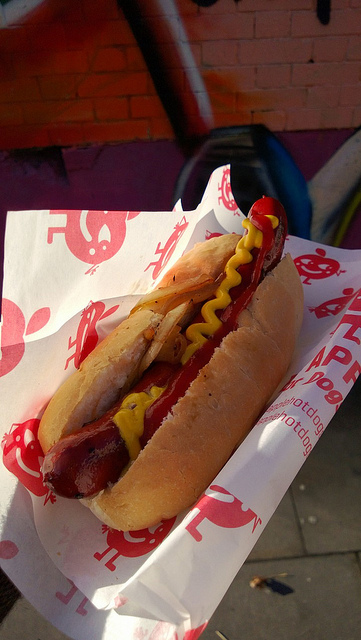Please transcribe the text in this image. hotdog hotdog APF 